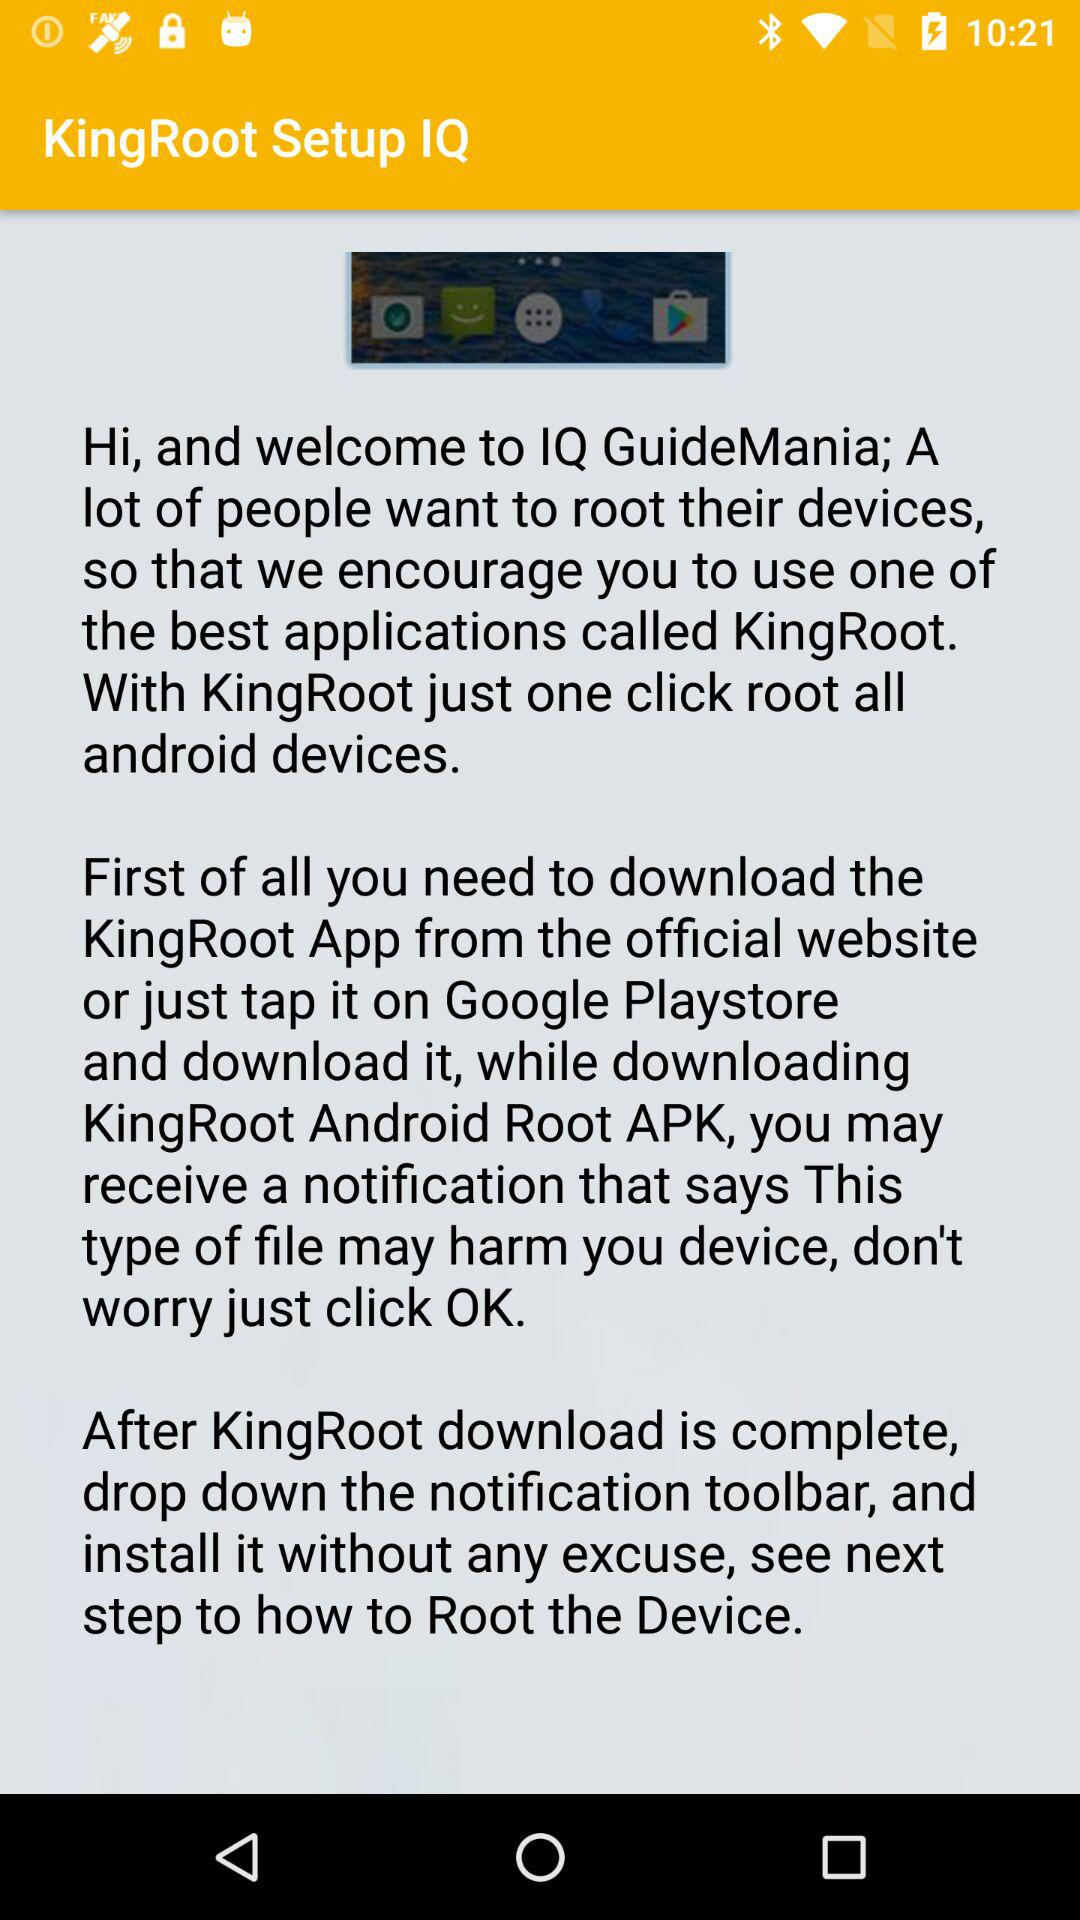What is the application name? The application name is "KingRoot Setup IQ". 